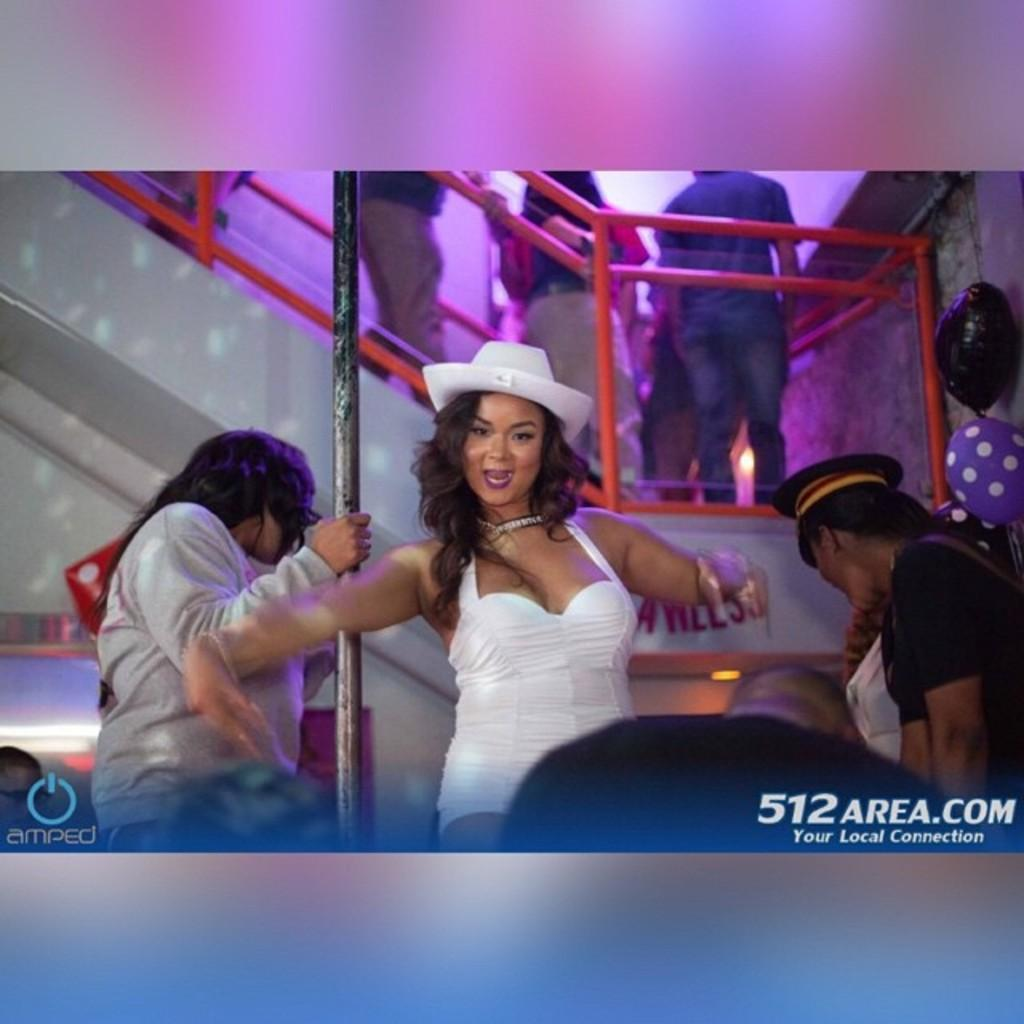Who is present in the image? There is a woman in the image. What is the woman wearing? The woman is wearing a white top. What is the woman doing in the image? The woman is dancing. What can be seen in the background of the image? There are steps in the background of the image. What color are the railing pipes on the steps? The railing pipes on the steps have a red color. Is the woman holding a gun in the image? No, the woman is not holding a gun in the image. Is there an army present in the image? No, there is no army present in the image. 